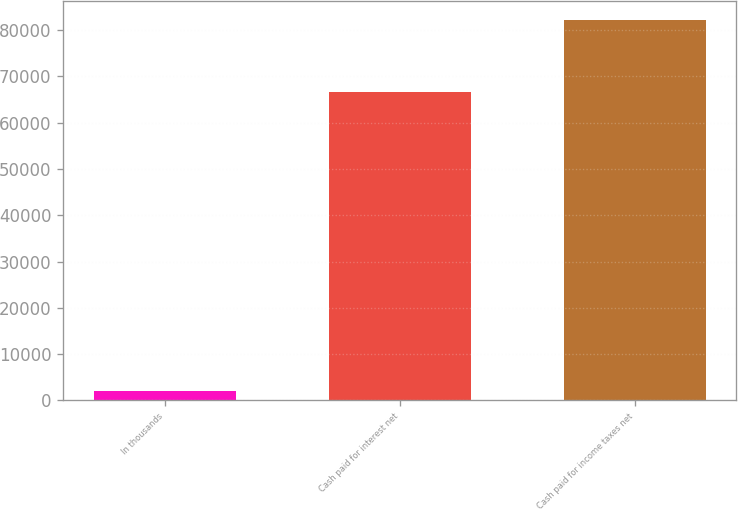Convert chart to OTSL. <chart><loc_0><loc_0><loc_500><loc_500><bar_chart><fcel>In thousands<fcel>Cash paid for interest net<fcel>Cash paid for income taxes net<nl><fcel>2012<fcel>66683<fcel>82235<nl></chart> 